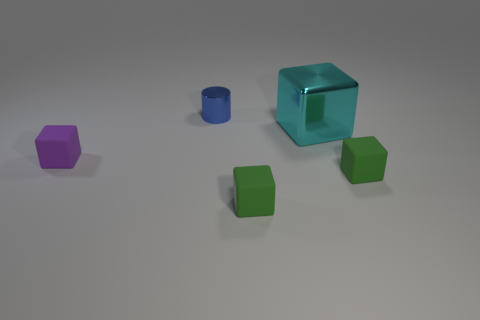What number of things are either purple things or cyan shiny blocks?
Give a very brief answer. 2. Is there another rubber object of the same size as the purple matte object?
Offer a very short reply. Yes. There is a purple object; what shape is it?
Keep it short and to the point. Cube. Are there more small purple blocks to the right of the small metal cylinder than objects in front of the cyan shiny object?
Give a very brief answer. No. Do the metal object on the left side of the large cyan block and the rubber cube to the right of the large cube have the same color?
Provide a short and direct response. No. The other metallic object that is the same size as the purple thing is what shape?
Keep it short and to the point. Cylinder. Are there any big metallic things of the same shape as the small purple thing?
Provide a short and direct response. Yes. Does the block that is behind the purple thing have the same material as the small cube on the left side of the small cylinder?
Offer a very short reply. No. How many other cylinders have the same material as the cylinder?
Your answer should be very brief. 0. What color is the large metal cube?
Provide a succinct answer. Cyan. 